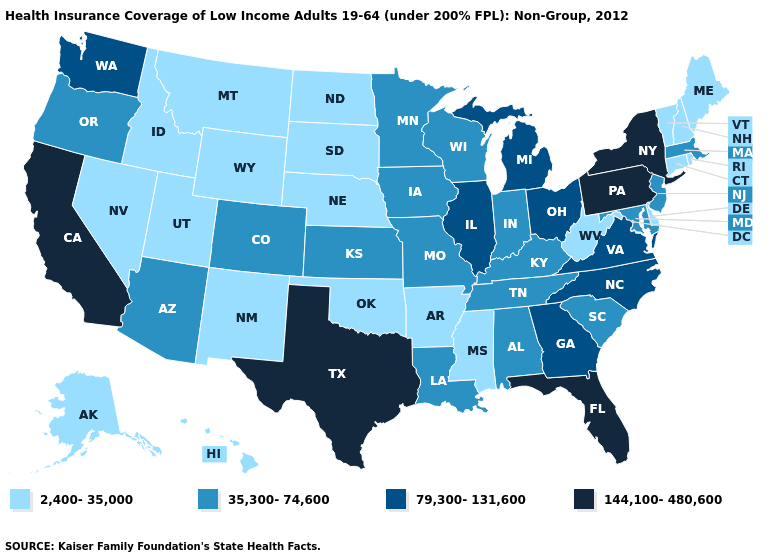What is the lowest value in the South?
Give a very brief answer. 2,400-35,000. Does Florida have the highest value in the South?
Short answer required. Yes. Is the legend a continuous bar?
Write a very short answer. No. Does Arkansas have a lower value than Maine?
Concise answer only. No. Name the states that have a value in the range 35,300-74,600?
Keep it brief. Alabama, Arizona, Colorado, Indiana, Iowa, Kansas, Kentucky, Louisiana, Maryland, Massachusetts, Minnesota, Missouri, New Jersey, Oregon, South Carolina, Tennessee, Wisconsin. What is the value of Michigan?
Quick response, please. 79,300-131,600. What is the value of New Mexico?
Write a very short answer. 2,400-35,000. What is the lowest value in the USA?
Answer briefly. 2,400-35,000. What is the value of Montana?
Give a very brief answer. 2,400-35,000. Does Texas have the highest value in the USA?
Be succinct. Yes. Does Colorado have a higher value than Virginia?
Keep it brief. No. Name the states that have a value in the range 79,300-131,600?
Answer briefly. Georgia, Illinois, Michigan, North Carolina, Ohio, Virginia, Washington. What is the value of Kentucky?
Give a very brief answer. 35,300-74,600. Name the states that have a value in the range 2,400-35,000?
Short answer required. Alaska, Arkansas, Connecticut, Delaware, Hawaii, Idaho, Maine, Mississippi, Montana, Nebraska, Nevada, New Hampshire, New Mexico, North Dakota, Oklahoma, Rhode Island, South Dakota, Utah, Vermont, West Virginia, Wyoming. Does the map have missing data?
Short answer required. No. 